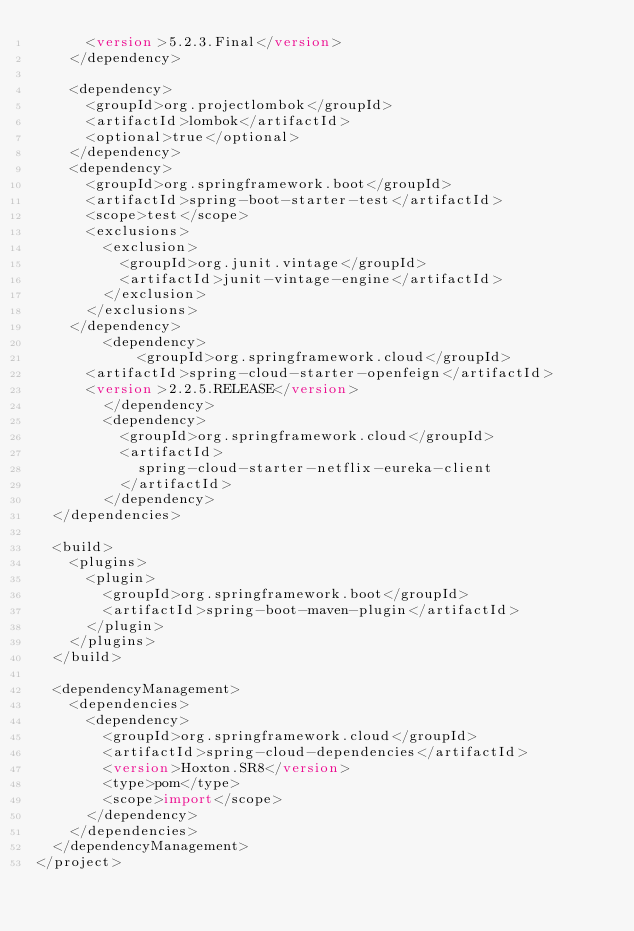<code> <loc_0><loc_0><loc_500><loc_500><_XML_>			<version>5.2.3.Final</version>
		</dependency>

		<dependency>
			<groupId>org.projectlombok</groupId>
			<artifactId>lombok</artifactId>
			<optional>true</optional>
		</dependency>
		<dependency>
			<groupId>org.springframework.boot</groupId>
			<artifactId>spring-boot-starter-test</artifactId>
			<scope>test</scope>
			<exclusions>
				<exclusion>
					<groupId>org.junit.vintage</groupId>
					<artifactId>junit-vintage-engine</artifactId>
				</exclusion>
			</exclusions>
		</dependency>
        <dependency>
            <groupId>org.springframework.cloud</groupId>
			<artifactId>spring-cloud-starter-openfeign</artifactId>
			<version>2.2.5.RELEASE</version>
        </dependency>
        <dependency>
        	<groupId>org.springframework.cloud</groupId>
        	<artifactId>
        		spring-cloud-starter-netflix-eureka-client
        	</artifactId>
        </dependency>
	</dependencies>

	<build>
		<plugins>
			<plugin>
				<groupId>org.springframework.boot</groupId>
				<artifactId>spring-boot-maven-plugin</artifactId>
			</plugin>
		</plugins>
	</build>

	<dependencyManagement>
		<dependencies>
			<dependency>
				<groupId>org.springframework.cloud</groupId>
				<artifactId>spring-cloud-dependencies</artifactId>
				<version>Hoxton.SR8</version>
				<type>pom</type>
				<scope>import</scope>
			</dependency>
		</dependencies>
	</dependencyManagement>
</project>
</code> 